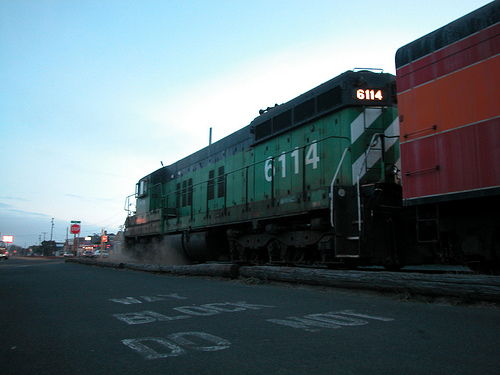Imagine the train is alive. What would it be thinking or feeling right now? If the train were alive, it might be feeling determined and focused, each chug and clank a testament to its resolve to reach its destination on time. It might also feel a sense of pride in its strength and service, cheerfully greeting every crossing it passes. At the sharegpt4v/same time, this train could carry an air of nostalgia, reminiscent of the many journeys and countless miles it has traversed over the years, ever eager for the new adventures that await down the tracks. 